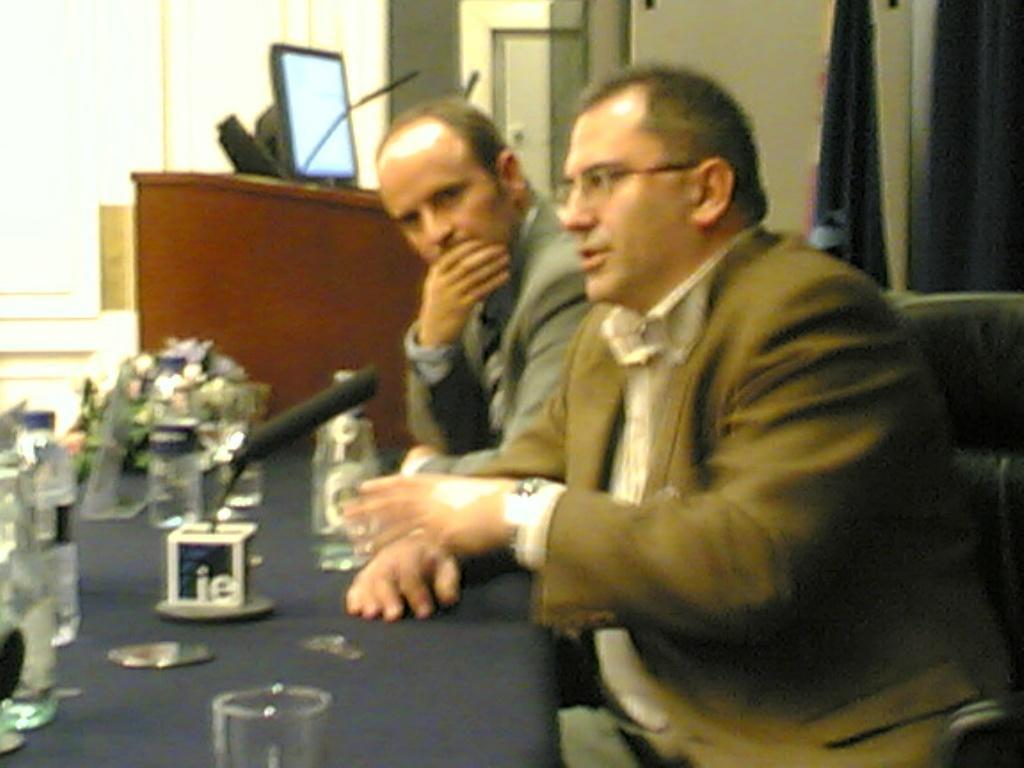Describe this image in one or two sentences. In this image, we can see a table, on that table there are some glasses and there are some bottles, at the right side there are two men sitting on the chairs, in the background we can see a monitor and there is a microphone. 